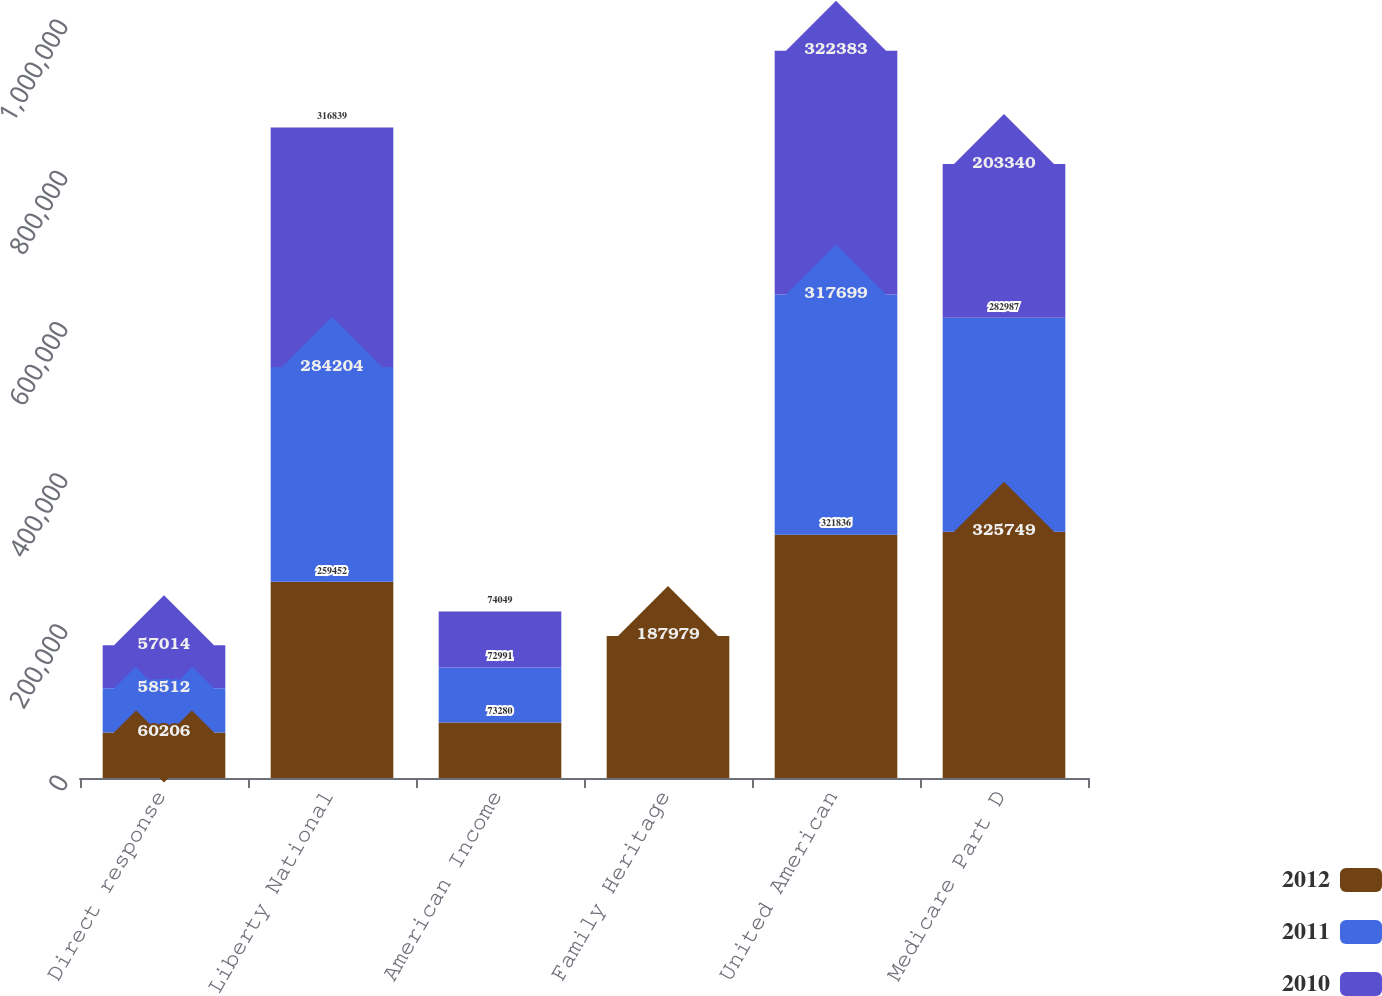Convert chart to OTSL. <chart><loc_0><loc_0><loc_500><loc_500><stacked_bar_chart><ecel><fcel>Direct response<fcel>Liberty National<fcel>American Income<fcel>Family Heritage<fcel>United American<fcel>Medicare Part D<nl><fcel>2012<fcel>60206<fcel>259452<fcel>73280<fcel>187979<fcel>321836<fcel>325749<nl><fcel>2011<fcel>58512<fcel>284204<fcel>72991<fcel>0<fcel>317699<fcel>282987<nl><fcel>2010<fcel>57014<fcel>316839<fcel>74049<fcel>0<fcel>322383<fcel>203340<nl></chart> 